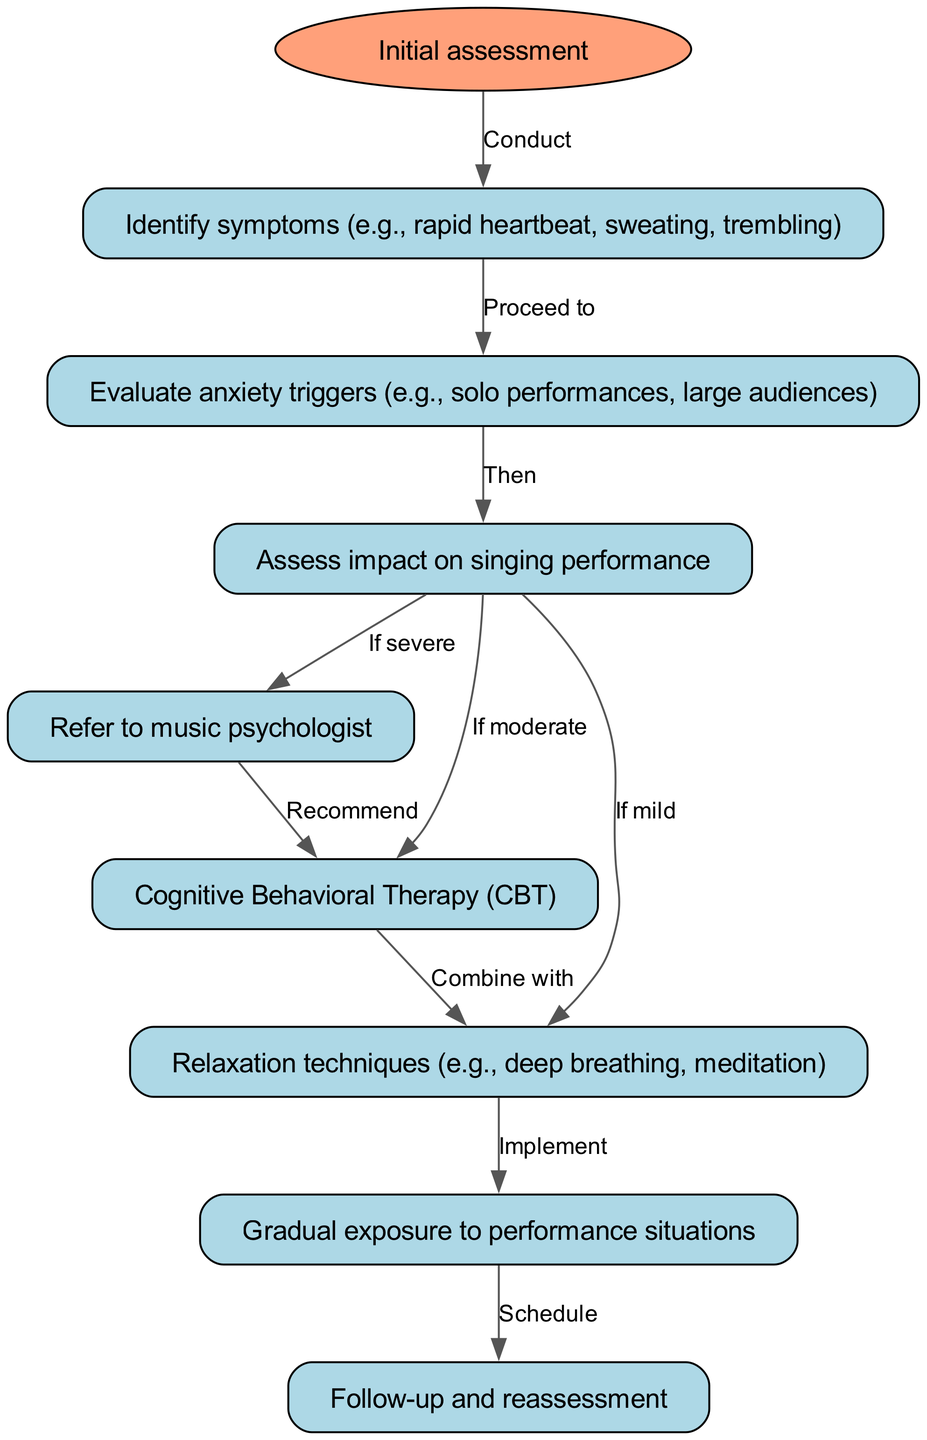What is the first step in the clinical pathway? The first step, indicated by the 'start' node, is labeled as "Initial assessment." This node represents the beginning of the clinical pathway.
Answer: Initial assessment How many nodes are present in the diagram? By counting each individual node shown in the diagram, there are a total of 8 nodes, including the starting point and the final follow-up.
Answer: 8 What follows after identifying symptoms? After identifying symptoms, the pathway indicates to "Evaluate anxiety triggers" as the next step in the diagram. This is shown by the directed edge connecting the two nodes.
Answer: Evaluate anxiety triggers What should be done if the impact on singing performance is assessed as severe? If the impact on singing performance is assessed as severe, the next step is to "Refer to music psychologist," based on the diagram's flow.
Answer: Refer to music psychologist What combination of therapies is suggested after Cognitive Behavioral Therapy? After Cognitive Behavioral Therapy, the pathway suggests combining it with "Relaxation techniques" as per the directed edge connecting these nodes in the diagram.
Answer: Relaxation techniques If a musician experiences mild anxiety, what intervention is indicated? For mild anxiety, the pathway shows that the next step is to implement "Relaxation techniques," linking it directly to the initial assessment of mild impact on performance.
Answer: Relaxation techniques What does the pathway suggest implementing after relaxation techniques? After relaxation techniques are implemented, the next step indicated in the clinical pathway is "Gradual exposure to performance situations," as shown in the diagram.
Answer: Gradual exposure to performance situations What is scheduled after gradual exposure to performance situations? The final step in the clinical pathway, following gradual exposure to performance situations, is "Follow-up and reassessment," indicating the need for subsequent evaluation.
Answer: Follow-up and reassessment 